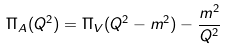Convert formula to latex. <formula><loc_0><loc_0><loc_500><loc_500>\Pi _ { A } ( Q ^ { 2 } ) = \Pi _ { V } ( Q ^ { 2 } - m ^ { 2 } ) - \frac { m ^ { 2 } } { Q ^ { 2 } }</formula> 